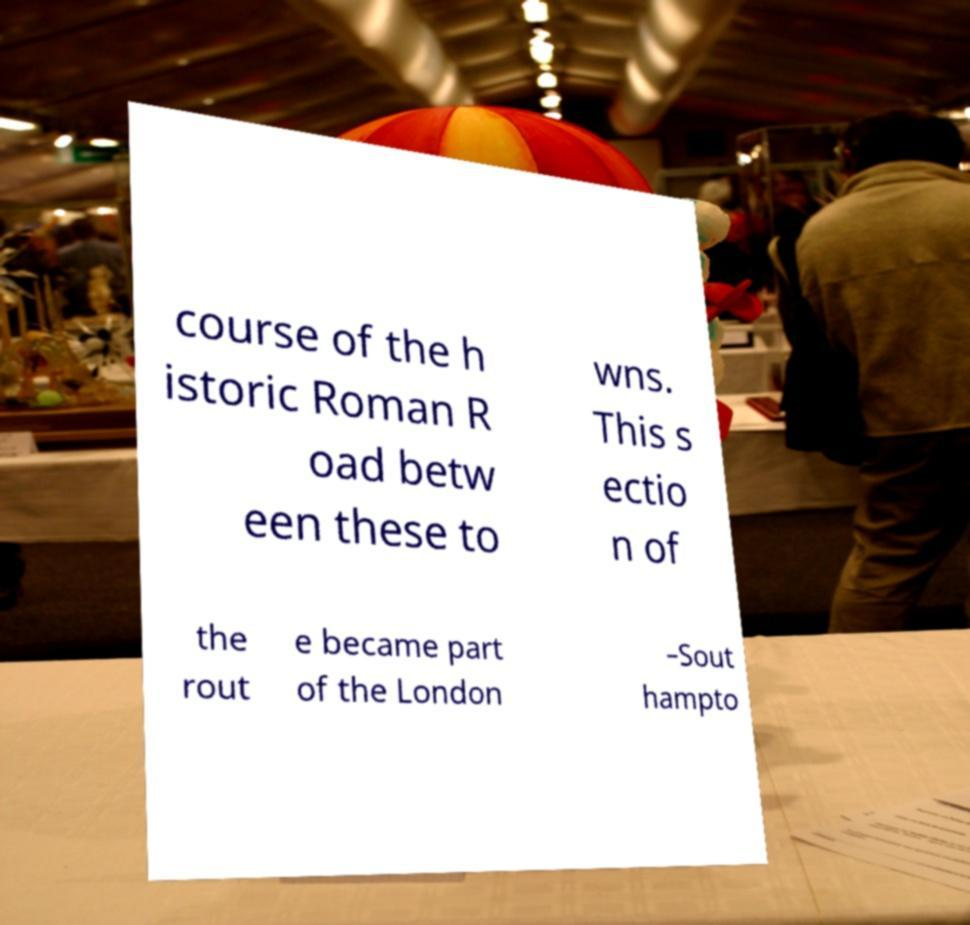Please read and relay the text visible in this image. What does it say? course of the h istoric Roman R oad betw een these to wns. This s ectio n of the rout e became part of the London –Sout hampto 